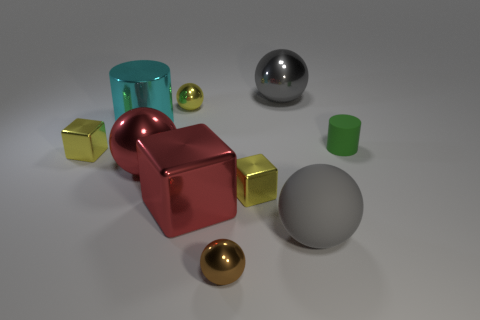Subtract all gray rubber balls. How many balls are left? 4 Subtract all brown cylinders. How many gray spheres are left? 2 Subtract all red spheres. How many spheres are left? 4 Subtract 1 balls. How many balls are left? 4 Subtract all blocks. How many objects are left? 7 Subtract all yellow blocks. Subtract all green cylinders. How many blocks are left? 1 Subtract all large red metal balls. Subtract all brown shiny spheres. How many objects are left? 8 Add 3 cyan metal objects. How many cyan metal objects are left? 4 Add 8 brown metal objects. How many brown metal objects exist? 9 Subtract 0 green spheres. How many objects are left? 10 